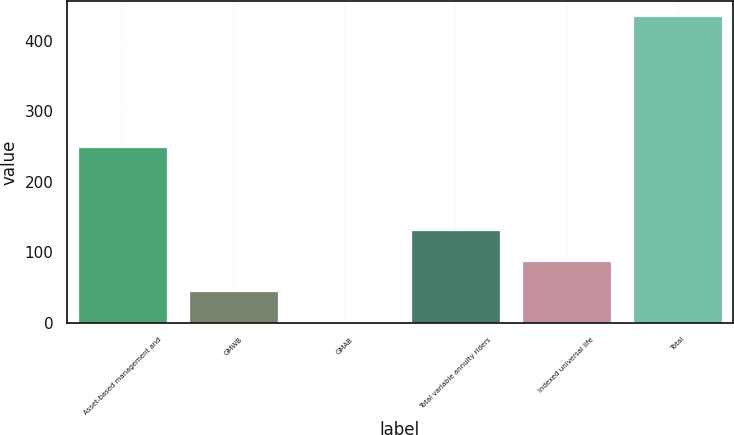Convert chart. <chart><loc_0><loc_0><loc_500><loc_500><bar_chart><fcel>Asset-based management and<fcel>GMWB<fcel>GMAB<fcel>Total variable annuity riders<fcel>Indexed universal life<fcel>Total<nl><fcel>250<fcel>45.3<fcel>2<fcel>131.9<fcel>88.6<fcel>435<nl></chart> 